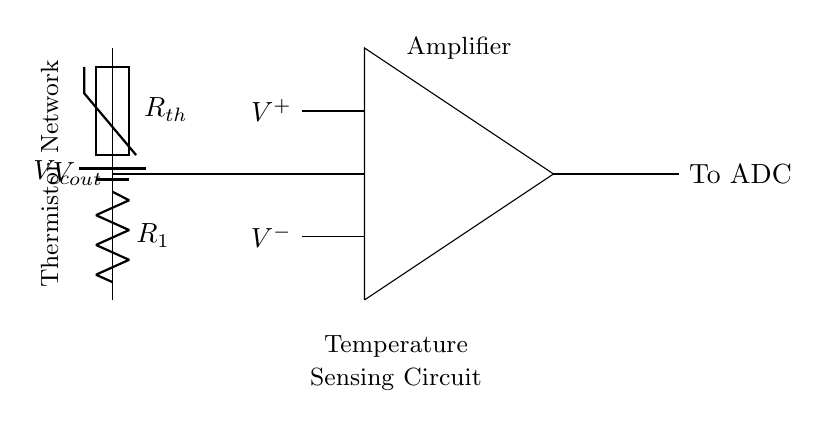What type of component is Rth? Rth is a thermistor, which is a type of resistor that changes resistance with temperature. It acts as a temperature-sensing element in the circuit.
Answer: thermistor What is the function of R1 in this circuit? R1 is used as part of a voltage divider with the thermistor. It helps to set the output voltage based on the resistance of the thermistor, allowing for temperature monitoring.
Answer: voltage divider What is the output voltage node labeled as? The output voltage from the voltage divider is labeled Vout. This is where the monitored temperature's voltage value can be taken for further processing.
Answer: Vout What is the purpose of the op-amp in this circuit? The op-amp amplifies the voltage difference between its input terminals, which allows for a stronger signal to be sent to the ADC for digitization.
Answer: amplifying signal How does the thermistor's resistance change with temperature? The resistance of the thermistor decreases with increasing temperature, allowing for variations in Vout that correspond to temperature changes, which is critical for accurate measurements.
Answer: decreases with temperature Where does the ADC receive its input from? The ADC receives its input from the output of the op-amp, which processes the Vout signal to convert it into a digital format for further analysis.
Answer: from op-amp output 